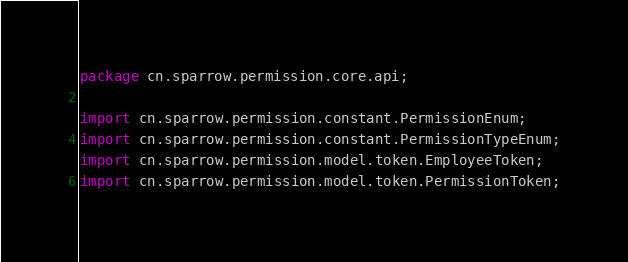Convert code to text. <code><loc_0><loc_0><loc_500><loc_500><_Java_>package cn.sparrow.permission.core.api;

import cn.sparrow.permission.constant.PermissionEnum;
import cn.sparrow.permission.constant.PermissionTypeEnum;
import cn.sparrow.permission.model.token.EmployeeToken;
import cn.sparrow.permission.model.token.PermissionToken;
</code> 